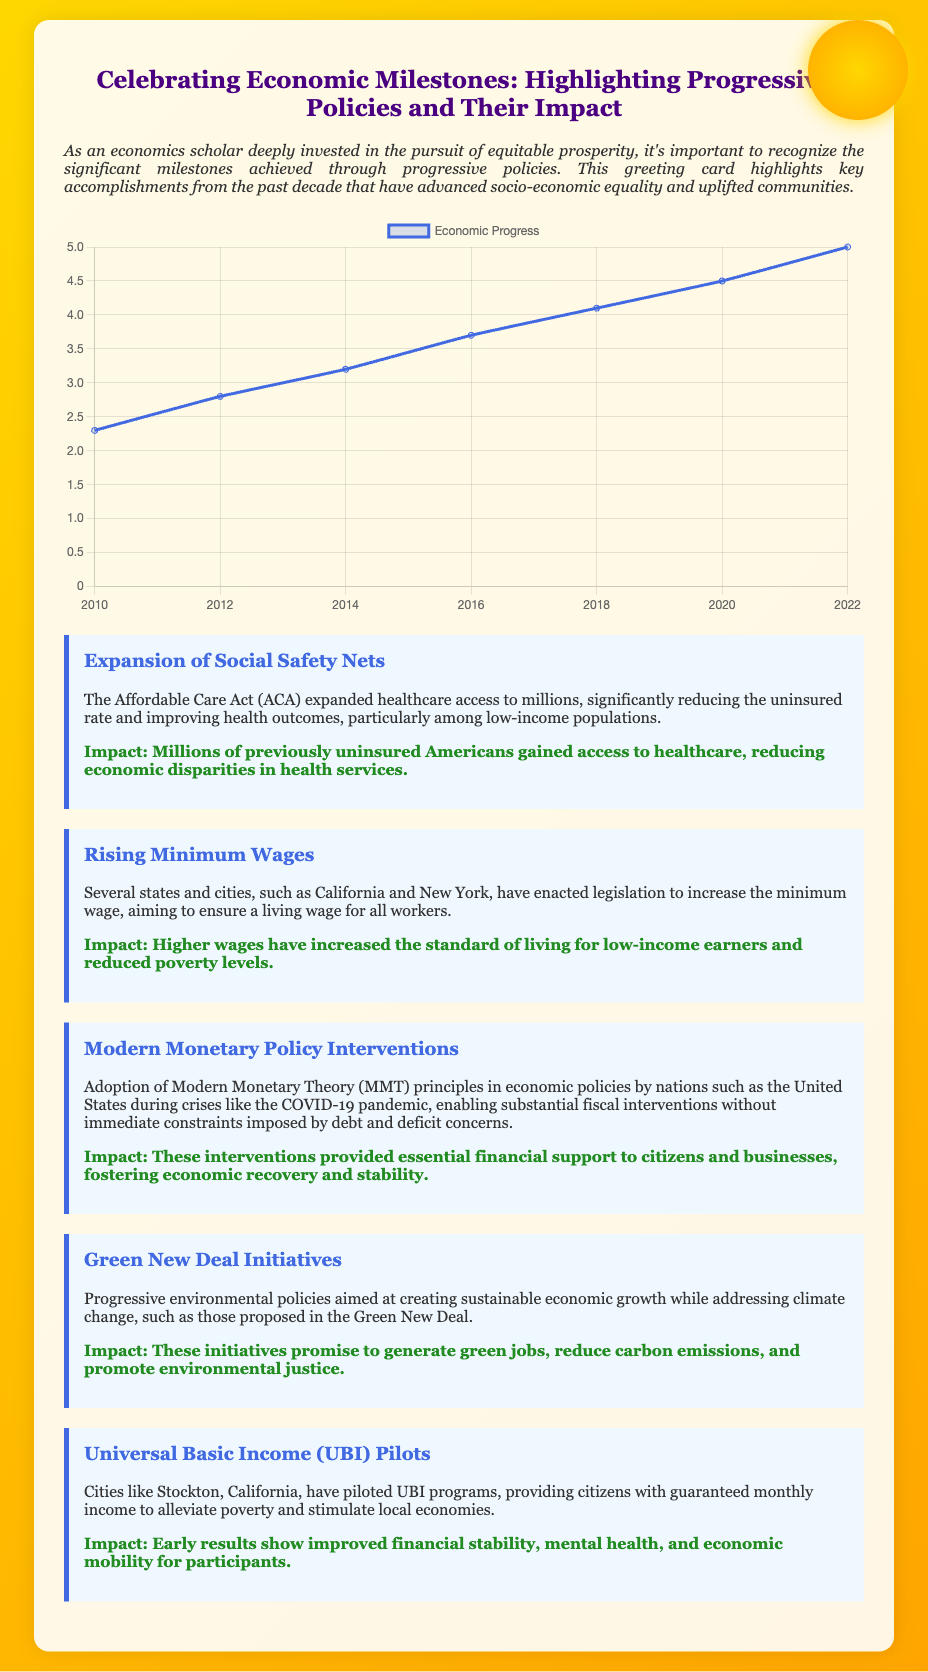What is the title of the card? The title of the card is presented at the top in a prominent position.
Answer: Celebrating Economic Milestones: Highlighting Progressive Policies and Their Impact What impact did the Affordable Care Act have? The impact is described in a specific paragraph, stating what outcomes the ACA achieved.
Answer: Millions of previously uninsured Americans gained access to healthcare, reducing economic disparities in health services Which states have raised the minimum wage? The card mentions specific states that enacted wage increases.
Answer: California and New York What is the main theme represented by the design's background? The rising sun in the design symbolizes a particular concept related to economic progress and hope.
Answer: Hope and progress What economic principle was used during the COVID-19 pandemic? This principle relates to fiscal policies and is mentioned in the context of modern interventions.
Answer: Modern Monetary Theory (MMT) 